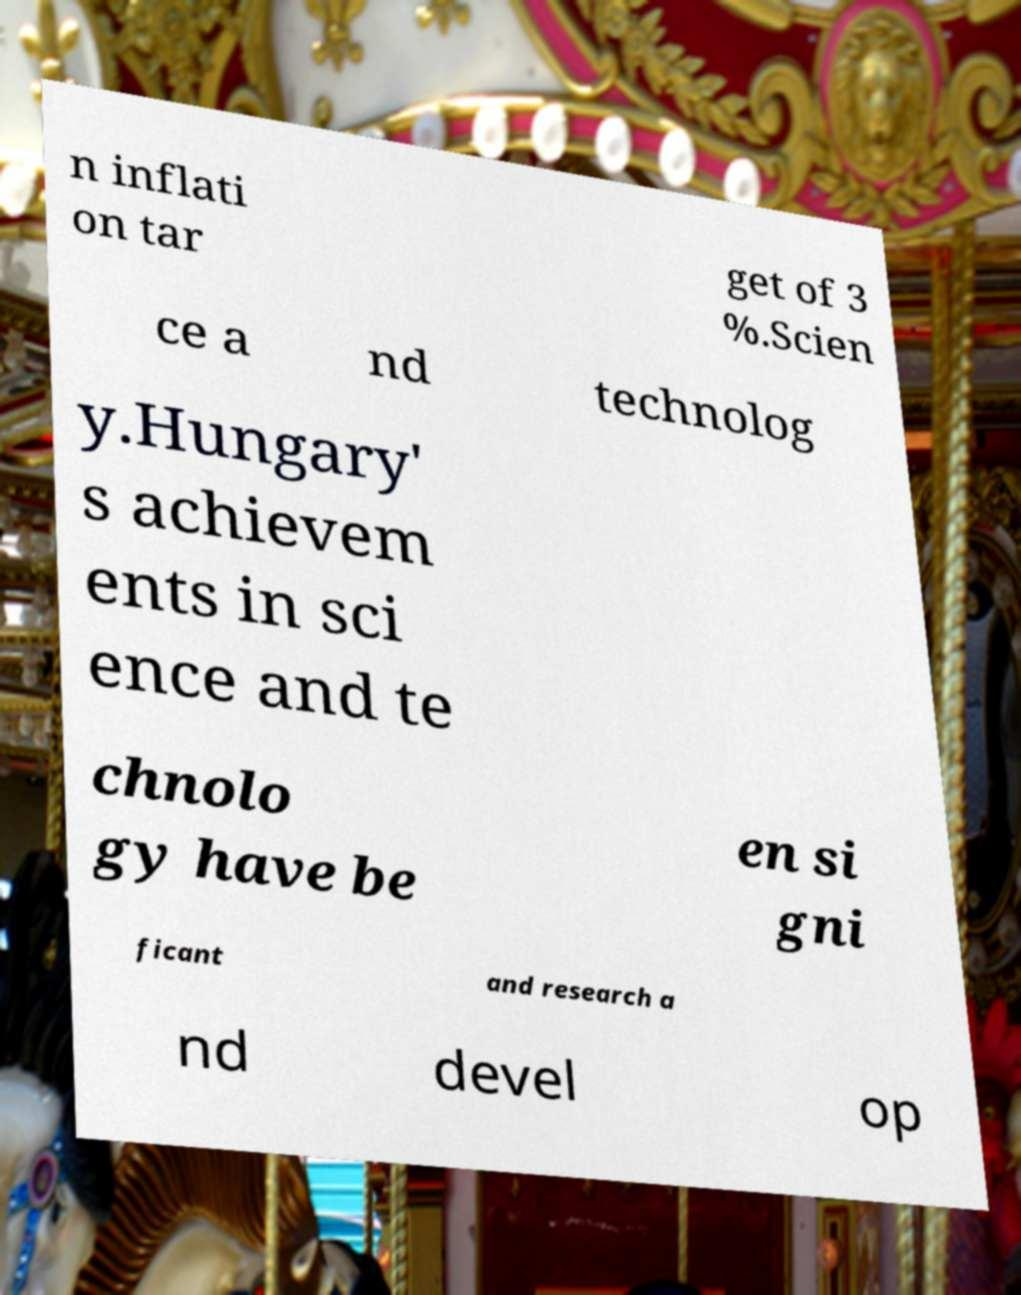Could you extract and type out the text from this image? n inflati on tar get of 3 %.Scien ce a nd technolog y.Hungary' s achievem ents in sci ence and te chnolo gy have be en si gni ficant and research a nd devel op 